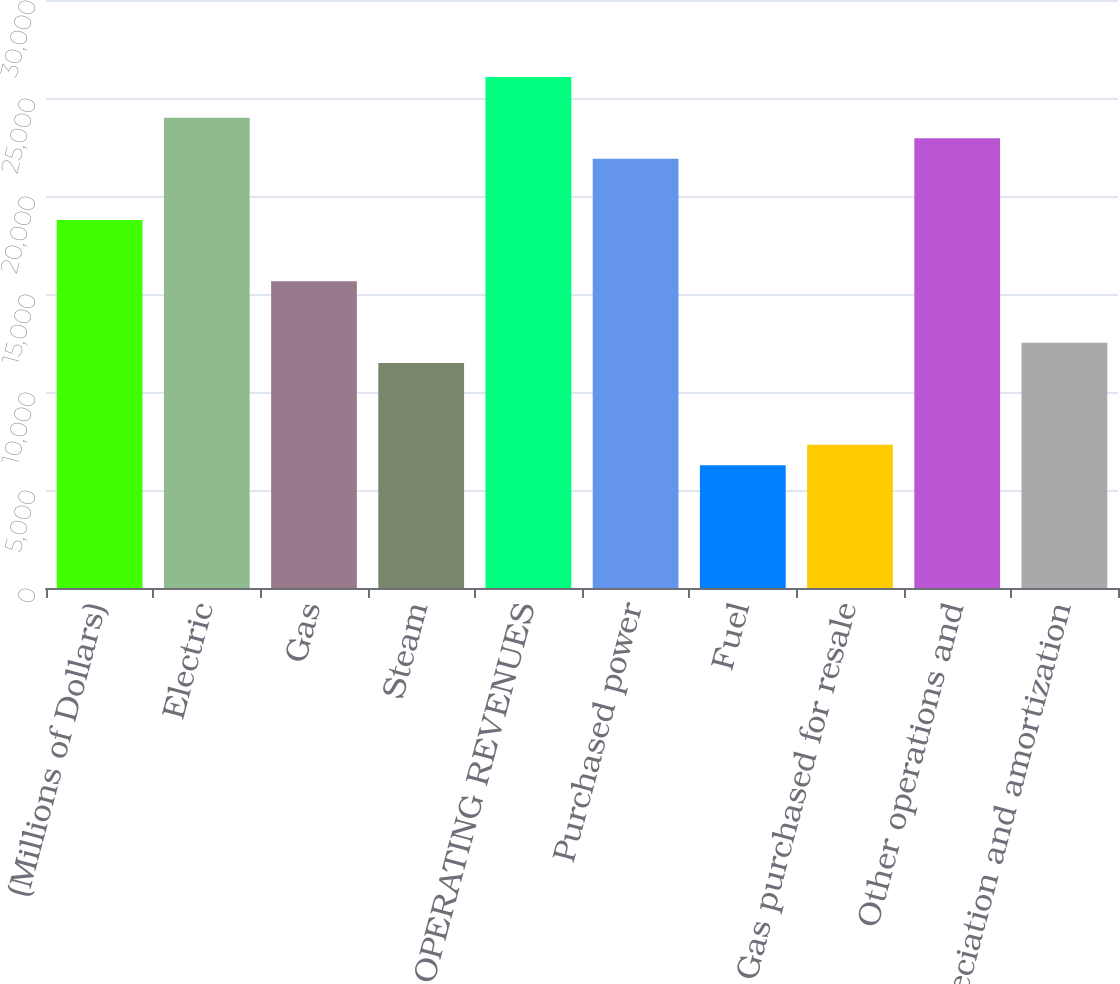Convert chart to OTSL. <chart><loc_0><loc_0><loc_500><loc_500><bar_chart><fcel>(Millions of Dollars)<fcel>Electric<fcel>Gas<fcel>Steam<fcel>TOTAL OPERATING REVENUES<fcel>Purchased power<fcel>Fuel<fcel>Gas purchased for resale<fcel>Other operations and<fcel>Depreciation and amortization<nl><fcel>18776<fcel>23991<fcel>15647<fcel>11475<fcel>26077<fcel>21905<fcel>6260<fcel>7303<fcel>22948<fcel>12518<nl></chart> 